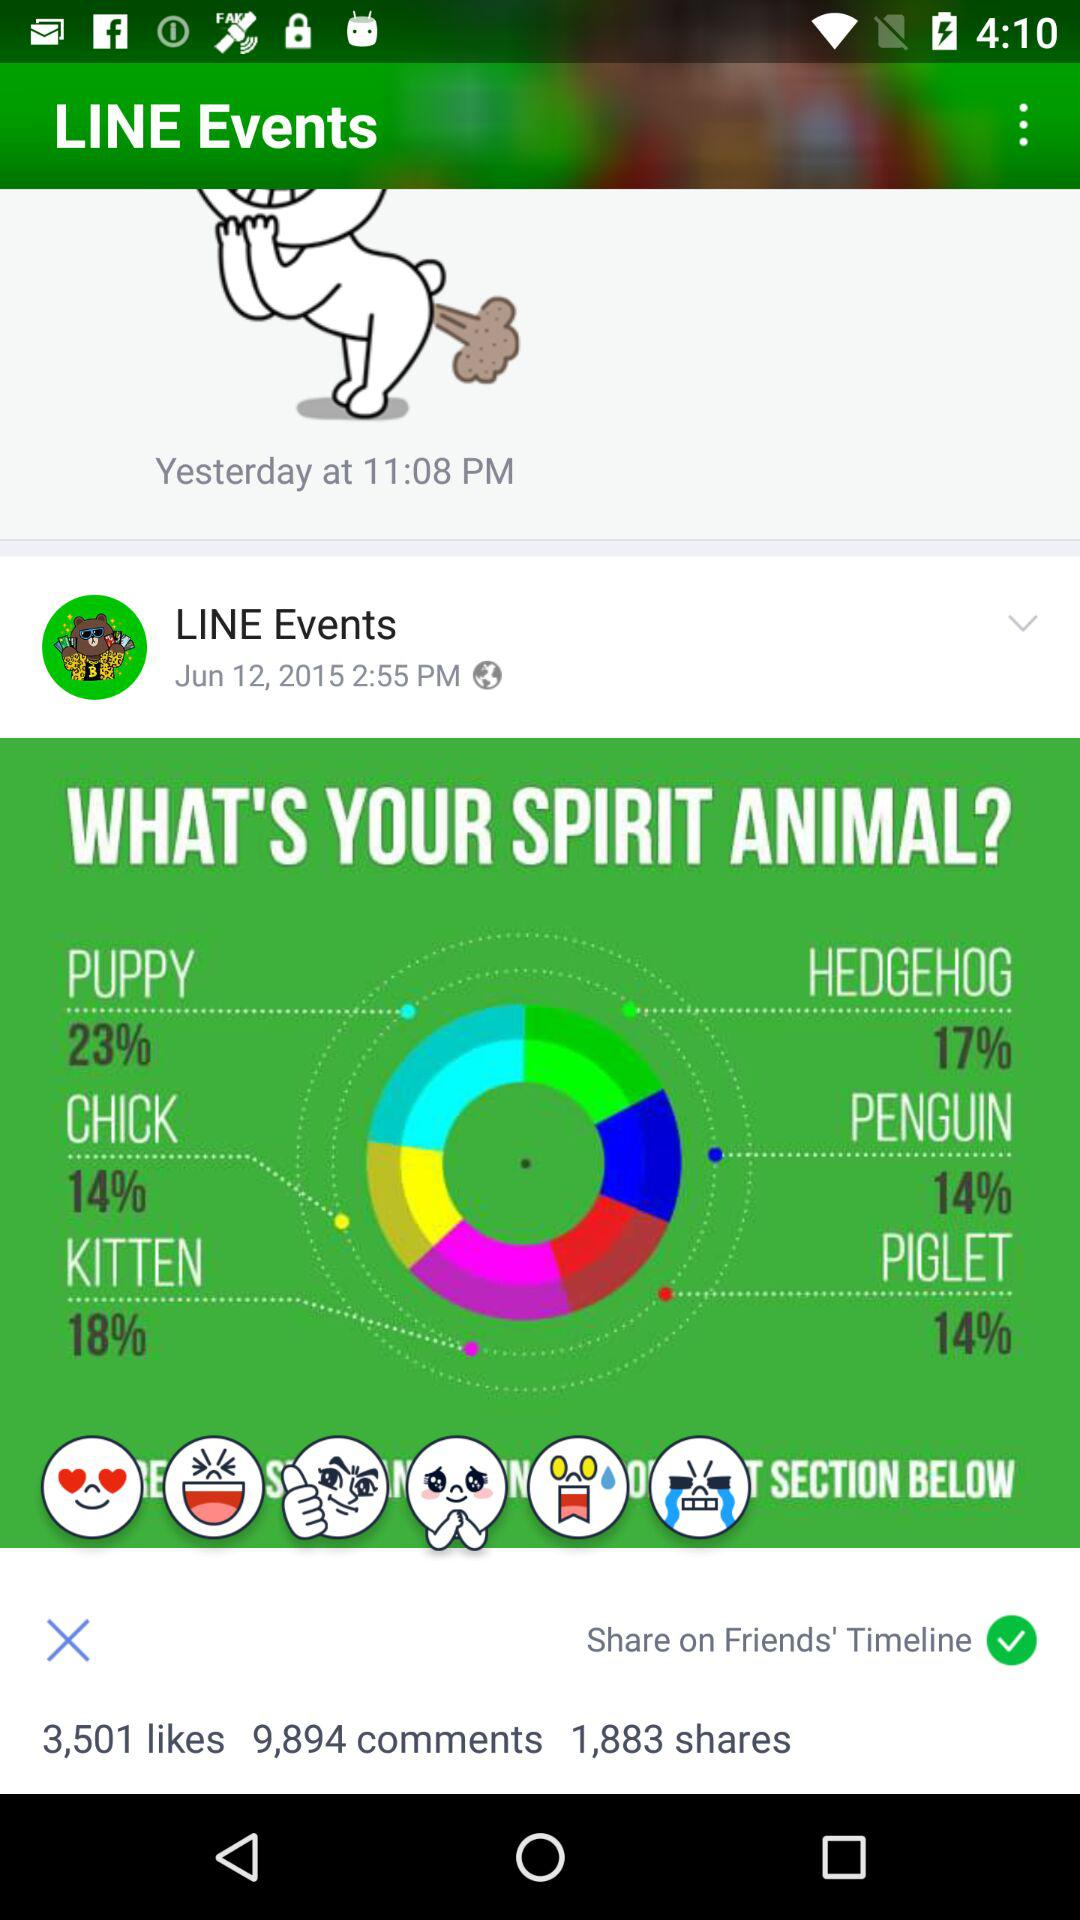How many likes did the post of "LINE Events" get? The post got 3,501 likes. 